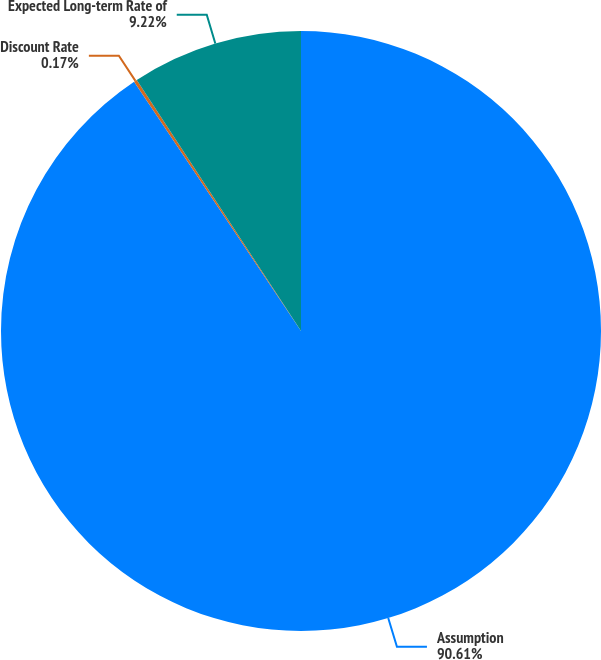<chart> <loc_0><loc_0><loc_500><loc_500><pie_chart><fcel>Assumption<fcel>Discount Rate<fcel>Expected Long-term Rate of<nl><fcel>90.61%<fcel>0.17%<fcel>9.22%<nl></chart> 